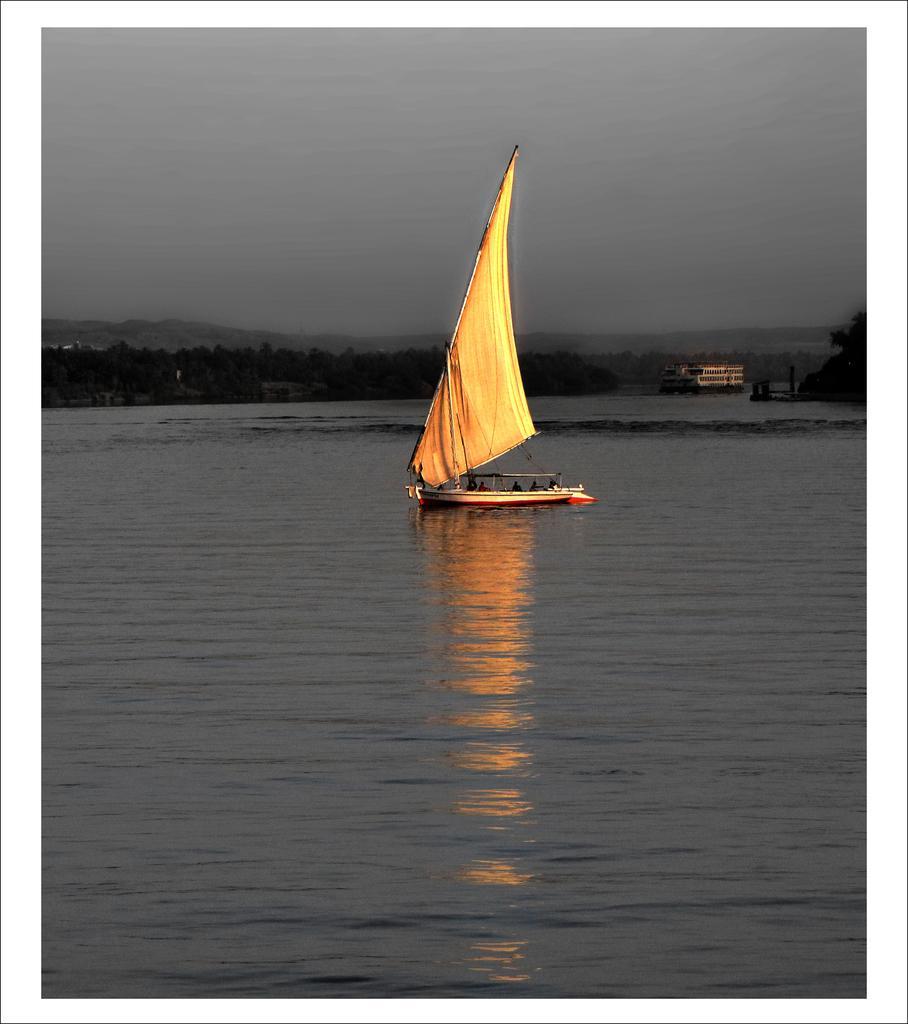How would you summarize this image in a sentence or two? In this picture I can see there is a boat sailing on the water and there are trees in the backdrop and I can see there is a building and the sky is cloudy. 